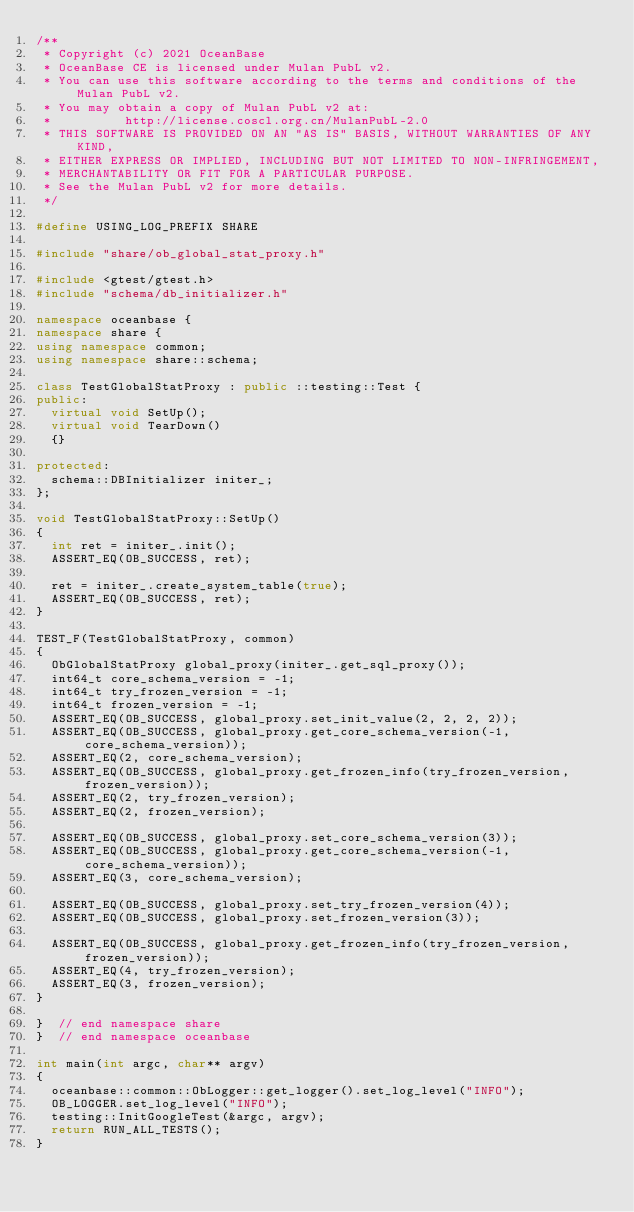<code> <loc_0><loc_0><loc_500><loc_500><_C++_>/**
 * Copyright (c) 2021 OceanBase
 * OceanBase CE is licensed under Mulan PubL v2.
 * You can use this software according to the terms and conditions of the Mulan PubL v2.
 * You may obtain a copy of Mulan PubL v2 at:
 *          http://license.coscl.org.cn/MulanPubL-2.0
 * THIS SOFTWARE IS PROVIDED ON AN "AS IS" BASIS, WITHOUT WARRANTIES OF ANY KIND,
 * EITHER EXPRESS OR IMPLIED, INCLUDING BUT NOT LIMITED TO NON-INFRINGEMENT,
 * MERCHANTABILITY OR FIT FOR A PARTICULAR PURPOSE.
 * See the Mulan PubL v2 for more details.
 */

#define USING_LOG_PREFIX SHARE

#include "share/ob_global_stat_proxy.h"

#include <gtest/gtest.h>
#include "schema/db_initializer.h"

namespace oceanbase {
namespace share {
using namespace common;
using namespace share::schema;

class TestGlobalStatProxy : public ::testing::Test {
public:
  virtual void SetUp();
  virtual void TearDown()
  {}

protected:
  schema::DBInitializer initer_;
};

void TestGlobalStatProxy::SetUp()
{
  int ret = initer_.init();
  ASSERT_EQ(OB_SUCCESS, ret);

  ret = initer_.create_system_table(true);
  ASSERT_EQ(OB_SUCCESS, ret);
}

TEST_F(TestGlobalStatProxy, common)
{
  ObGlobalStatProxy global_proxy(initer_.get_sql_proxy());
  int64_t core_schema_version = -1;
  int64_t try_frozen_version = -1;
  int64_t frozen_version = -1;
  ASSERT_EQ(OB_SUCCESS, global_proxy.set_init_value(2, 2, 2, 2));
  ASSERT_EQ(OB_SUCCESS, global_proxy.get_core_schema_version(-1, core_schema_version));
  ASSERT_EQ(2, core_schema_version);
  ASSERT_EQ(OB_SUCCESS, global_proxy.get_frozen_info(try_frozen_version, frozen_version));
  ASSERT_EQ(2, try_frozen_version);
  ASSERT_EQ(2, frozen_version);

  ASSERT_EQ(OB_SUCCESS, global_proxy.set_core_schema_version(3));
  ASSERT_EQ(OB_SUCCESS, global_proxy.get_core_schema_version(-1, core_schema_version));
  ASSERT_EQ(3, core_schema_version);

  ASSERT_EQ(OB_SUCCESS, global_proxy.set_try_frozen_version(4));
  ASSERT_EQ(OB_SUCCESS, global_proxy.set_frozen_version(3));

  ASSERT_EQ(OB_SUCCESS, global_proxy.get_frozen_info(try_frozen_version, frozen_version));
  ASSERT_EQ(4, try_frozen_version);
  ASSERT_EQ(3, frozen_version);
}

}  // end namespace share
}  // end namespace oceanbase

int main(int argc, char** argv)
{
  oceanbase::common::ObLogger::get_logger().set_log_level("INFO");
  OB_LOGGER.set_log_level("INFO");
  testing::InitGoogleTest(&argc, argv);
  return RUN_ALL_TESTS();
}
</code> 